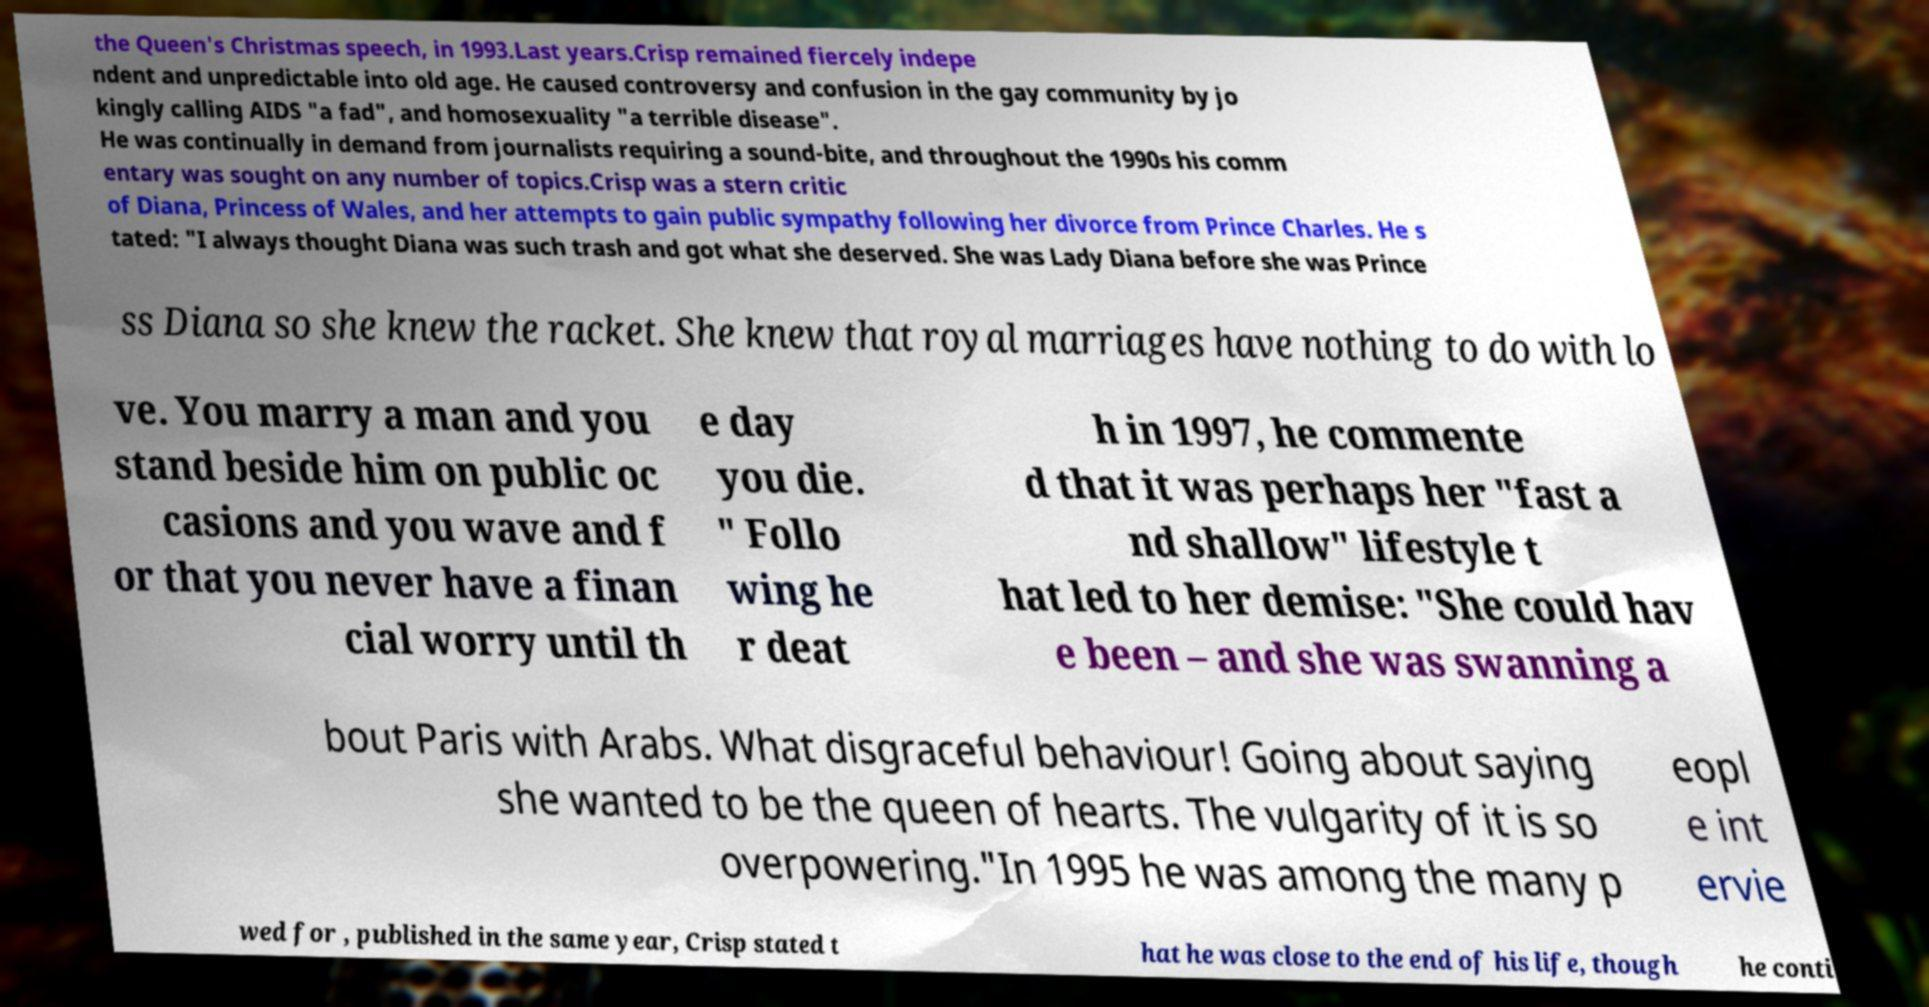Could you extract and type out the text from this image? the Queen's Christmas speech, in 1993.Last years.Crisp remained fiercely indepe ndent and unpredictable into old age. He caused controversy and confusion in the gay community by jo kingly calling AIDS "a fad", and homosexuality "a terrible disease". He was continually in demand from journalists requiring a sound-bite, and throughout the 1990s his comm entary was sought on any number of topics.Crisp was a stern critic of Diana, Princess of Wales, and her attempts to gain public sympathy following her divorce from Prince Charles. He s tated: "I always thought Diana was such trash and got what she deserved. She was Lady Diana before she was Prince ss Diana so she knew the racket. She knew that royal marriages have nothing to do with lo ve. You marry a man and you stand beside him on public oc casions and you wave and f or that you never have a finan cial worry until th e day you die. " Follo wing he r deat h in 1997, he commente d that it was perhaps her "fast a nd shallow" lifestyle t hat led to her demise: "She could hav e been – and she was swanning a bout Paris with Arabs. What disgraceful behaviour! Going about saying she wanted to be the queen of hearts. The vulgarity of it is so overpowering."In 1995 he was among the many p eopl e int ervie wed for , published in the same year, Crisp stated t hat he was close to the end of his life, though he conti 